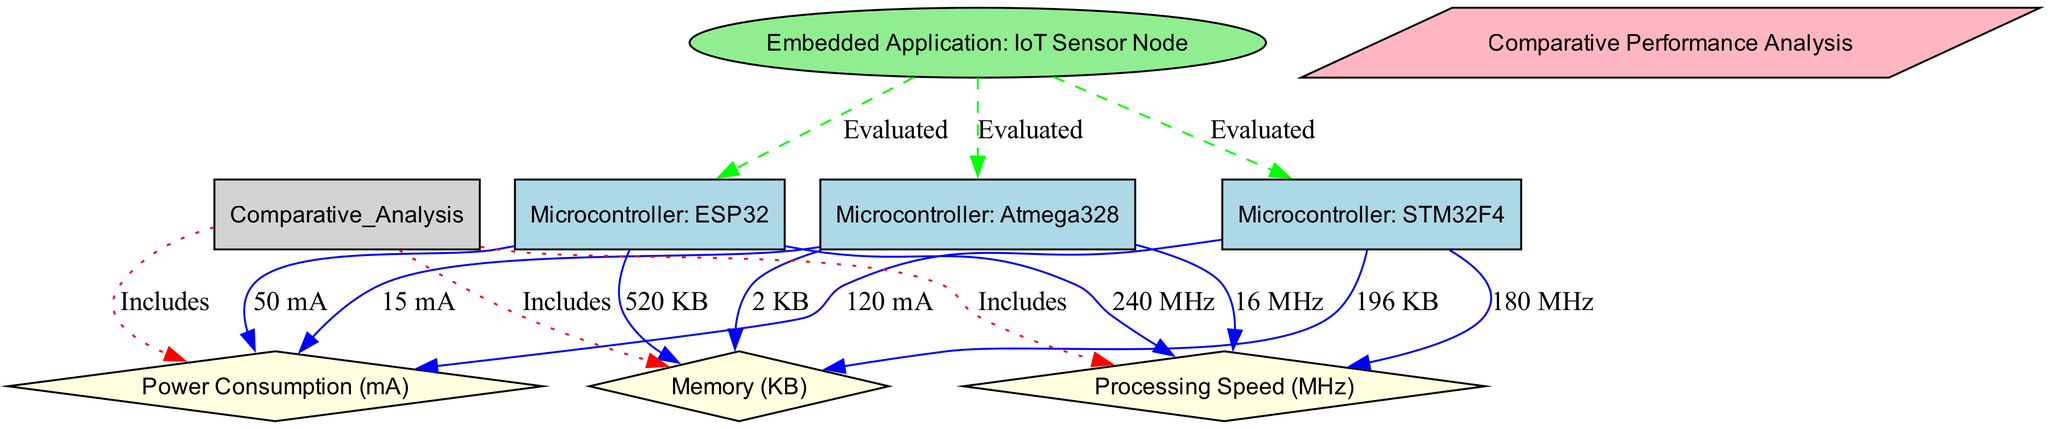What is the processing speed of Microcontroller: ESP32? The diagram indicates that the processing speed for Microcontroller: ESP32 is directly linked to the parameter node and labeled as 240 MHz. This can be found by locating the node for Microcontroller: ESP32 and following the edge that leads to the processing speed parameter.
Answer: 240 MHz What is the power consumption of Microcontroller: Atmega328? In the diagram, the power consumption for Microcontroller: Atmega328 is noted as 15 mA. This information is retrieved by locating the Atmega328 node and identifying its corresponding power consumption edge.
Answer: 15 mA How many microcontrollers are evaluated for the IoT Sensor Node application? The diagram shows three microcontrollers (ESP32, STM32F4, and Atmega328) that are all connected to the IoT Sensor Node application through evaluated edges. Counting these nodes gives the total number of evaluated microcontrollers.
Answer: 3 Which microcontroller has the highest memory? By comparing the memory values associated with each microcontroller in the diagram, ESP32 has 520 KB, STM32F4 has 196 KB, and Atmega328 has 2 KB. The highest value of 520 KB is linked to the ESP32 node.
Answer: Microcontroller: ESP32 Which microcontroller has the lowest processing speed? In the diagram, the processing speeds are 240 MHz for ESP32, 180 MHz for STM32F4, and 16 MHz for Atmega328. To determine the lowest, we compare these values, and we can see that Atmega328 has the lowest at 16 MHz.
Answer: Atmega328 What is the relationship between the Comparative Performance Analysis and the power consumption parameter? The relationship is defined by an edge labeled "Includes" that connects the Comparative Performance Analysis node to the power consumption parameter. This indicates that power consumption is a part of the comparative analysis.
Answer: Includes Which microcontroller consumes the most power? By examining the power consumption values: 50 mA for ESP32, 120 mA for STM32F4, and 15 mA for Atmega328, it is evident that STM32F4 has the highest power consumption at 120 mA.
Answer: Microcontroller: STM32F4 Is memory included in the Comparative Performance Analysis? Yes, the memory parameter is directly connected to the Comparative Performance Analysis node with an "Includes" edge, indicating that memory is indeed considered in the analysis.
Answer: Yes What is the processing speed of Microcontroller: STM32F4? The diagram shows that the processing speed linked to the STM32F4 node is labeled as 180 MHz. This is found by examining the edge that connects STM32F4 to its processing speed parameter.
Answer: 180 MHz 